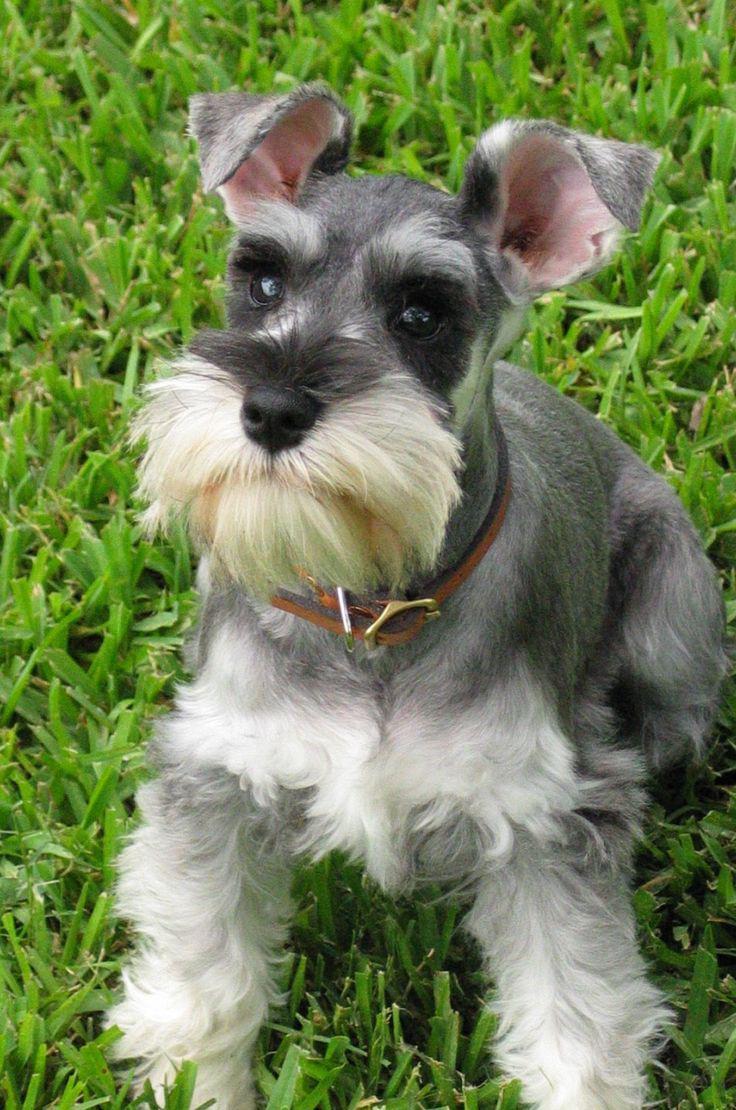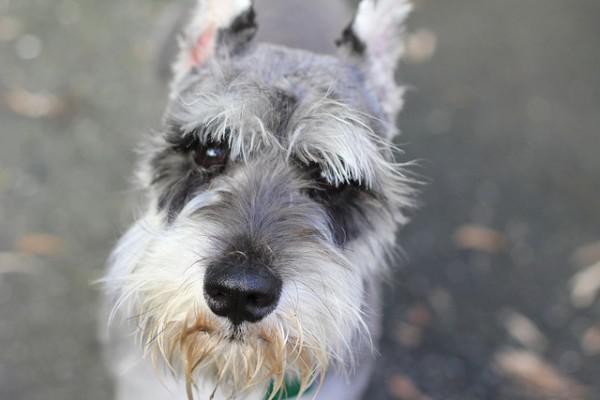The first image is the image on the left, the second image is the image on the right. Evaluate the accuracy of this statement regarding the images: "Greenery is visible in an image of a schnauzer.". Is it true? Answer yes or no. Yes. 